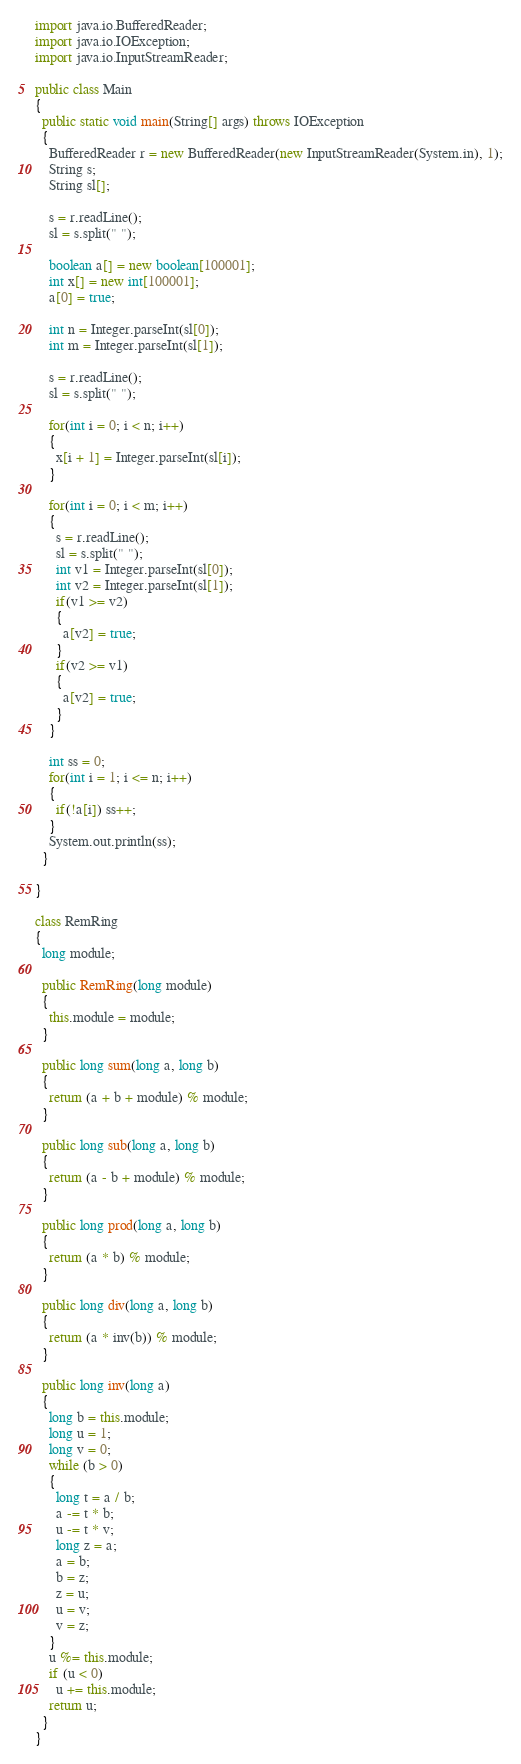Convert code to text. <code><loc_0><loc_0><loc_500><loc_500><_Java_>import java.io.BufferedReader;
import java.io.IOException;
import java.io.InputStreamReader;

public class Main
{
  public static void main(String[] args) throws IOException
  {
    BufferedReader r = new BufferedReader(new InputStreamReader(System.in), 1);
    String s;
    String sl[];

    s = r.readLine();
    sl = s.split(" ");

    boolean a[] = new boolean[100001];
    int x[] = new int[100001];
    a[0] = true;

    int n = Integer.parseInt(sl[0]);
    int m = Integer.parseInt(sl[1]);

    s = r.readLine();
    sl = s.split(" ");

    for(int i = 0; i < n; i++)
    {
      x[i + 1] = Integer.parseInt(sl[i]);
    }

    for(int i = 0; i < m; i++)
    {
      s = r.readLine();
      sl = s.split(" ");
      int v1 = Integer.parseInt(sl[0]);
      int v2 = Integer.parseInt(sl[1]);
      if(v1 >= v2)
      {
        a[v2] = true;
      }
      if(v2 >= v1)
      {
        a[v2] = true;
      }
    }

    int ss = 0;
    for(int i = 1; i <= n; i++)
    {
      if(!a[i]) ss++;
    }
    System.out.println(ss);
  }

}

class RemRing
{
  long module;

  public RemRing(long module)
  {
    this.module = module;
  }

  public long sum(long a, long b)
  {
    return (a + b + module) % module;
  }

  public long sub(long a, long b)
  {
    return (a - b + module) % module;
  }

  public long prod(long a, long b)
  {
    return (a * b) % module;
  }

  public long div(long a, long b)
  {
    return (a * inv(b)) % module;
  }

  public long inv(long a)
  {
    long b = this.module;
    long u = 1;
    long v = 0;
    while (b > 0)
    {
      long t = a / b;
      a -= t * b;
      u -= t * v;
      long z = a;
      a = b;
      b = z;
      z = u;
      u = v;
      v = z;
    }
    u %= this.module;
    if (u < 0)
      u += this.module;
    return u;
  }
}</code> 